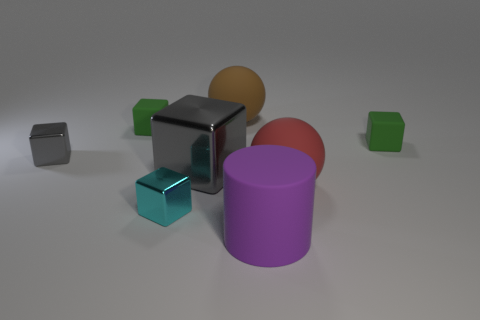What number of other objects are there of the same color as the large metallic object?
Your response must be concise. 1. Is the cylinder the same color as the large block?
Offer a very short reply. No. There is a gray thing that is the same size as the purple matte thing; what is it made of?
Make the answer very short. Metal. What is the tiny thing on the right side of the cyan cube that is in front of the large rubber thing left of the big purple rubber object made of?
Your answer should be very brief. Rubber. What color is the big metal object?
Provide a succinct answer. Gray. How many tiny things are either purple cylinders or blue balls?
Your answer should be very brief. 0. There is another block that is the same color as the large cube; what is its material?
Keep it short and to the point. Metal. Do the green thing that is to the right of the big red object and the tiny green block to the left of the tiny cyan block have the same material?
Provide a short and direct response. Yes. Are any cubes visible?
Your answer should be very brief. Yes. Are there more gray things that are behind the large red matte ball than cylinders behind the cylinder?
Your response must be concise. Yes. 